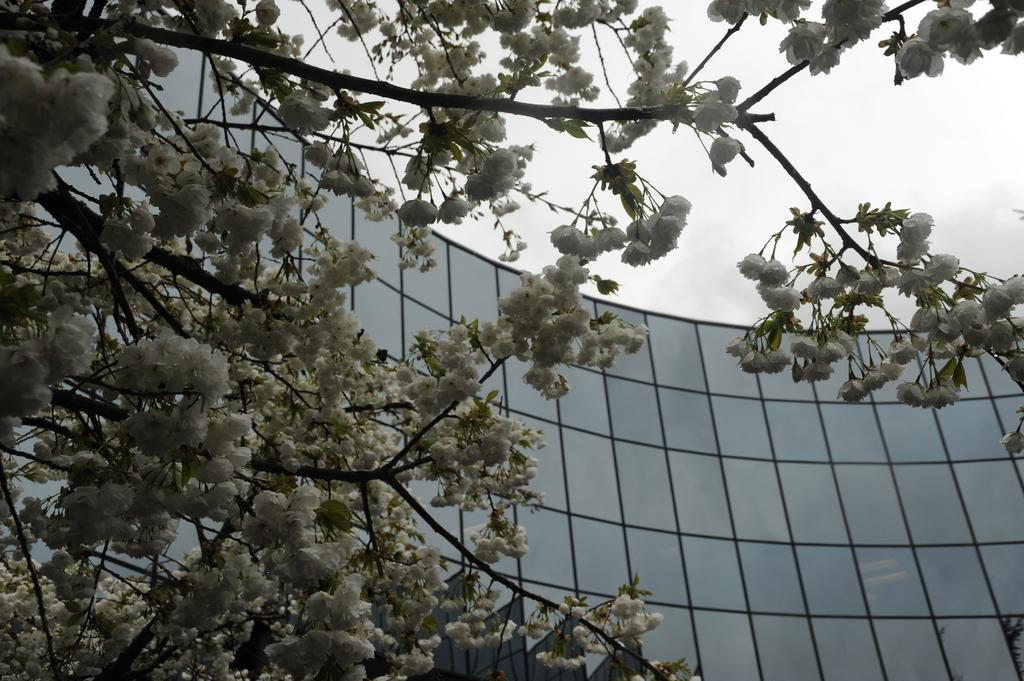What is the main object in the image? There is a tree in the image. What can be seen on the tree? There are flowers on the tree, and they are white in color. What is visible in the background of the image? There is a building and the sky visible in the background of the image. Where can the cobweb be found in the image? There is no cobweb present in the image. What type of play is happening in the image? There is no play or any indication of a play happening in the image. 